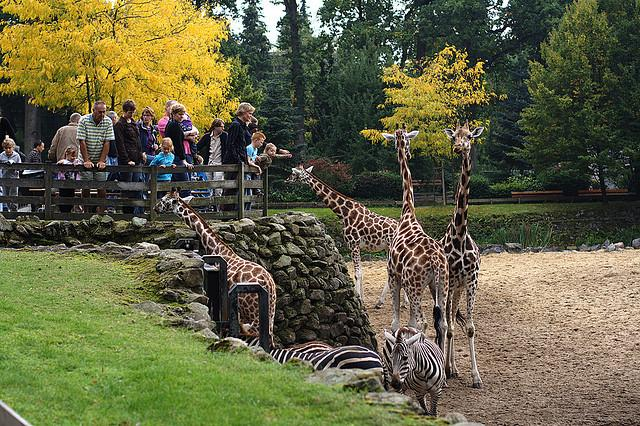What is closest to the giraffe? zebra 